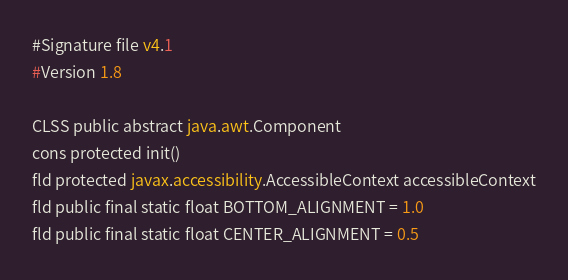<code> <loc_0><loc_0><loc_500><loc_500><_SML_>#Signature file v4.1
#Version 1.8

CLSS public abstract java.awt.Component
cons protected init()
fld protected javax.accessibility.AccessibleContext accessibleContext
fld public final static float BOTTOM_ALIGNMENT = 1.0
fld public final static float CENTER_ALIGNMENT = 0.5</code> 